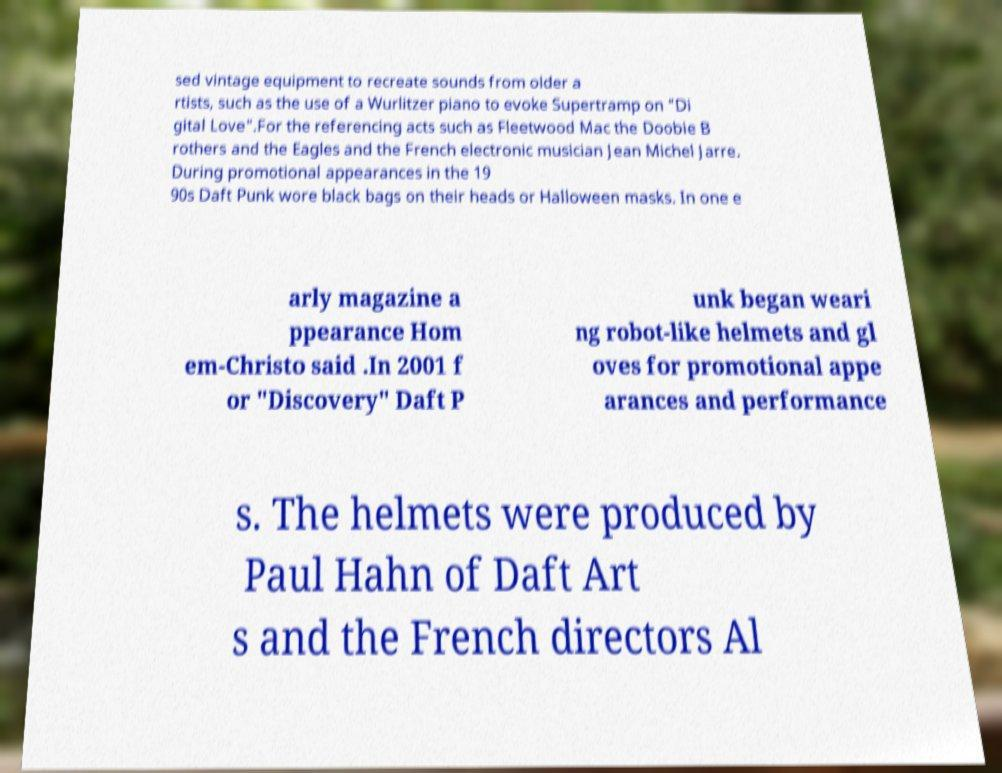Can you read and provide the text displayed in the image?This photo seems to have some interesting text. Can you extract and type it out for me? sed vintage equipment to recreate sounds from older a rtists, such as the use of a Wurlitzer piano to evoke Supertramp on "Di gital Love".For the referencing acts such as Fleetwood Mac the Doobie B rothers and the Eagles and the French electronic musician Jean Michel Jarre. During promotional appearances in the 19 90s Daft Punk wore black bags on their heads or Halloween masks. In one e arly magazine a ppearance Hom em-Christo said .In 2001 f or "Discovery" Daft P unk began weari ng robot-like helmets and gl oves for promotional appe arances and performance s. The helmets were produced by Paul Hahn of Daft Art s and the French directors Al 